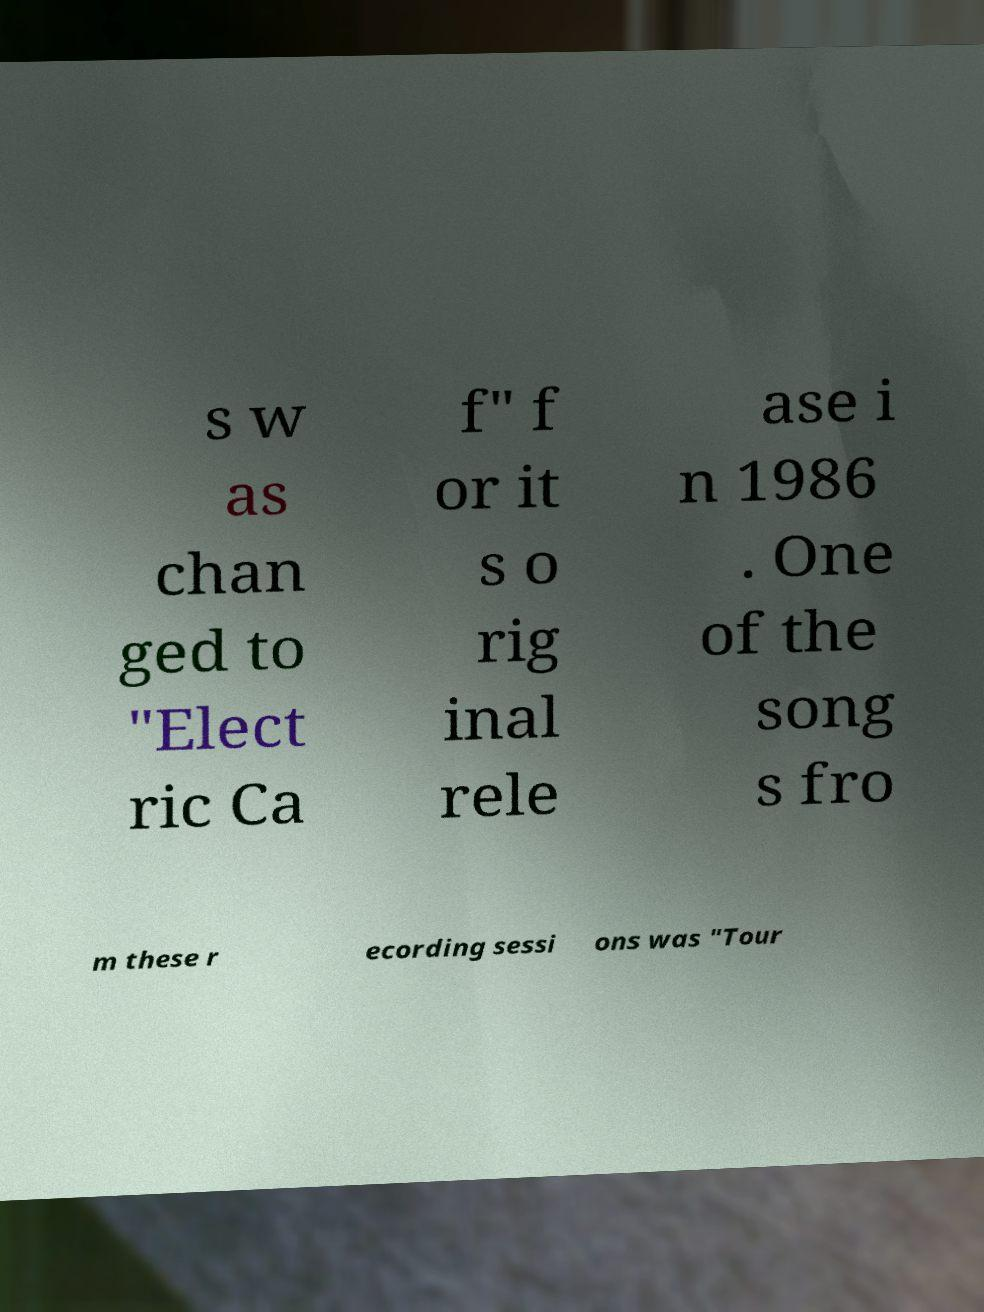Can you read and provide the text displayed in the image?This photo seems to have some interesting text. Can you extract and type it out for me? s w as chan ged to "Elect ric Ca f" f or it s o rig inal rele ase i n 1986 . One of the song s fro m these r ecording sessi ons was "Tour 